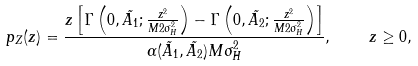<formula> <loc_0><loc_0><loc_500><loc_500>p _ { Z } ( z ) = \frac { z \left [ \Gamma \left ( 0 , \tilde { A _ { 1 } } ; \frac { z ^ { 2 } } { M 2 \sigma _ { H } ^ { 2 } } \right ) - \Gamma \left ( 0 , \tilde { A _ { 2 } } ; \frac { z ^ { 2 } } { M 2 \sigma _ { H } ^ { 2 } } \right ) \right ] } { \alpha ( \tilde { A _ { 1 } } , \tilde { A _ { 2 } } ) M \sigma _ { H } ^ { 2 } } , \quad z \geq 0 ,</formula> 